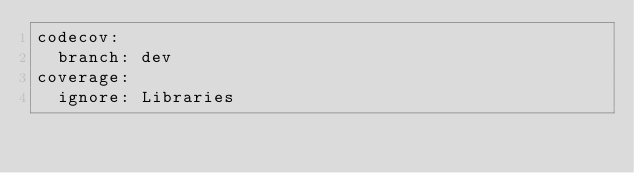Convert code to text. <code><loc_0><loc_0><loc_500><loc_500><_YAML_>codecov:
  branch: dev
coverage:
  ignore: Libraries
</code> 